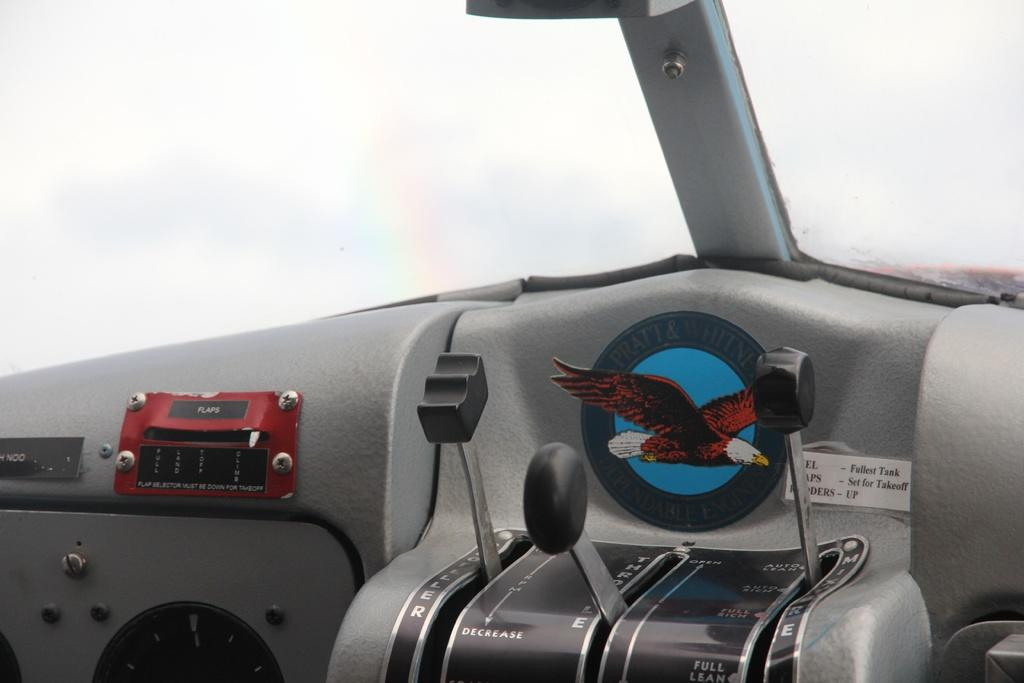What type of system parts are visible in the image? The image contains driving system parts of an airplane. Is there any branding or identification in the image? Yes, there is a logo visible in the image. What type of windows are present in the image? The image includes glass windows. Where is the indication meter located in the image? The indication meter is on the bottom left side of the image. What team is responsible for the design of the yoke in the image? There is no yoke present in the image, and therefore no team responsible for its design. 